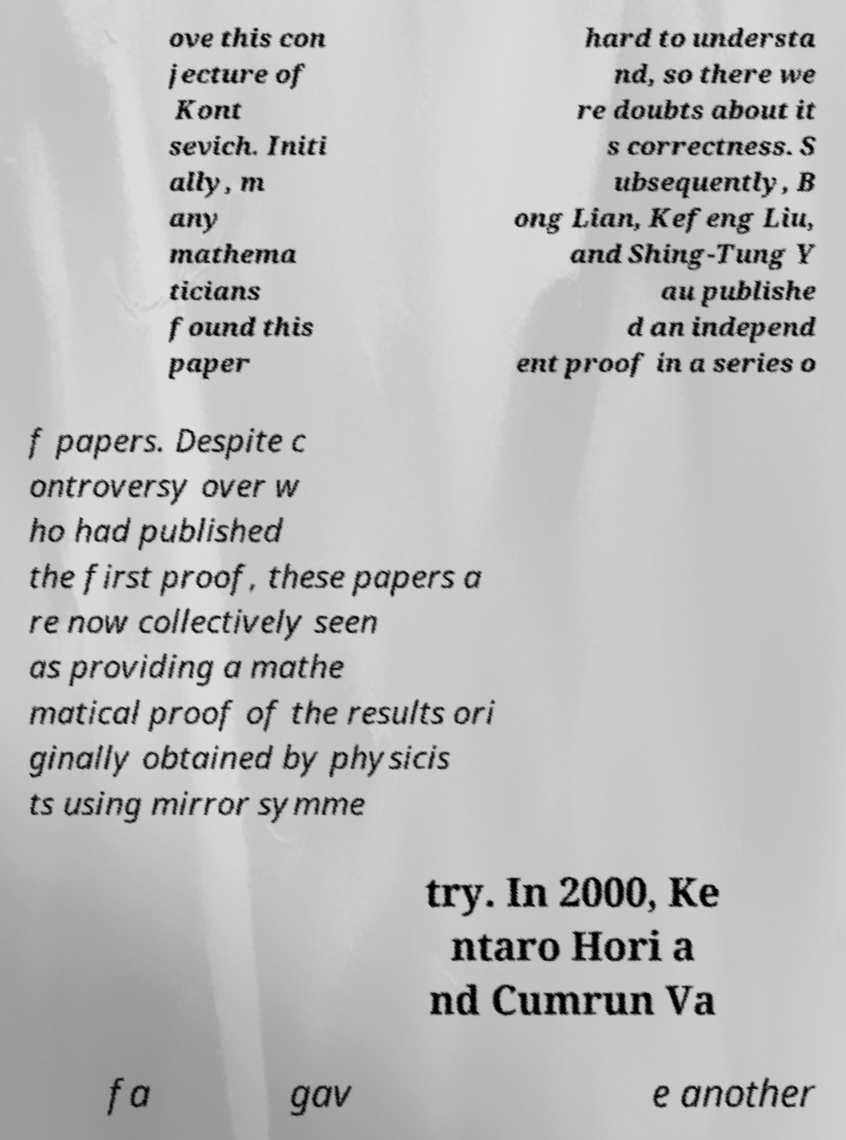Can you accurately transcribe the text from the provided image for me? ove this con jecture of Kont sevich. Initi ally, m any mathema ticians found this paper hard to understa nd, so there we re doubts about it s correctness. S ubsequently, B ong Lian, Kefeng Liu, and Shing-Tung Y au publishe d an independ ent proof in a series o f papers. Despite c ontroversy over w ho had published the first proof, these papers a re now collectively seen as providing a mathe matical proof of the results ori ginally obtained by physicis ts using mirror symme try. In 2000, Ke ntaro Hori a nd Cumrun Va fa gav e another 